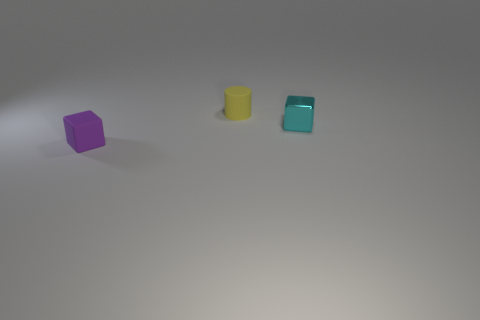There is a tiny matte thing to the left of the object behind the metal block; are there any tiny rubber cylinders behind it?
Offer a terse response. Yes. There is another object that is the same shape as the purple thing; what size is it?
Your answer should be compact. Small. Is there anything else that has the same material as the yellow cylinder?
Provide a short and direct response. Yes. Are any purple blocks visible?
Offer a terse response. Yes. There is a small cylinder; is it the same color as the block in front of the metal thing?
Provide a succinct answer. No. What size is the cube on the right side of the block to the left of the small cube on the right side of the tiny purple rubber block?
Offer a terse response. Small. What number of objects are tiny matte cylinders or tiny blocks that are behind the small purple matte object?
Provide a short and direct response. 2. The matte cylinder is what color?
Your answer should be very brief. Yellow. There is a object that is behind the cyan metal thing; what is its color?
Your answer should be compact. Yellow. There is a cube that is on the right side of the tiny purple object; how many blocks are to the right of it?
Give a very brief answer. 0. 